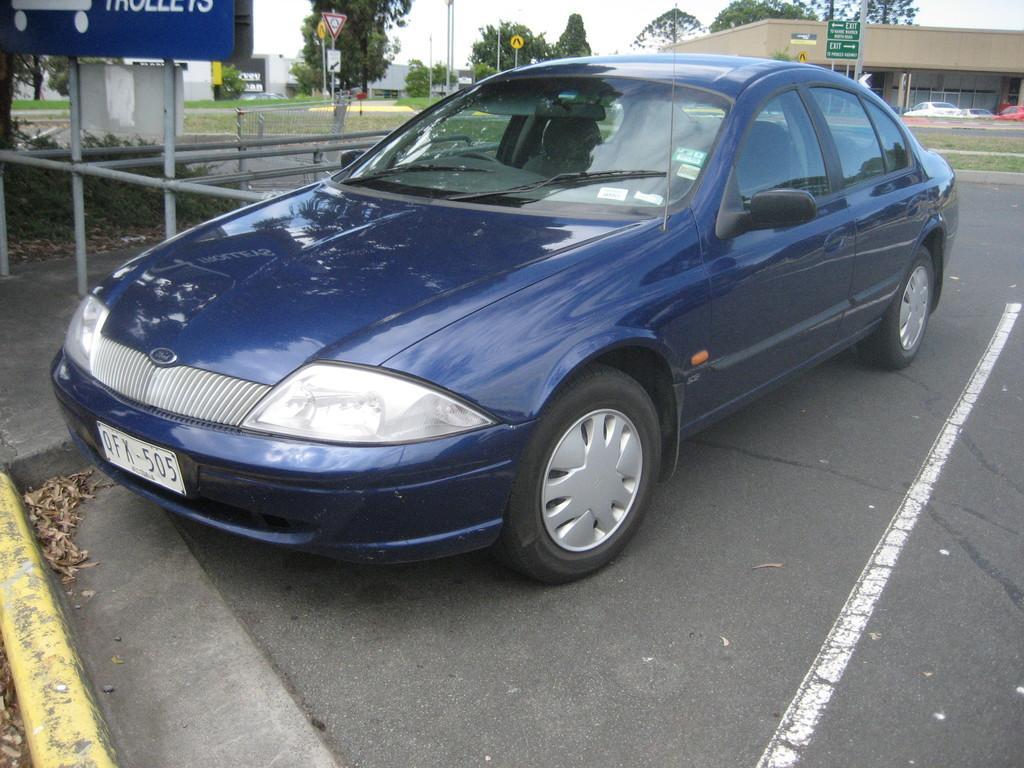Please provide a concise description of this image. In this image, we can see a car which is colored blue. There is a board in the top left of the image. There are some trees and sign boards at the top of the image. There is a building in the top right of the image. 